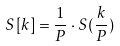Convert formula to latex. <formula><loc_0><loc_0><loc_500><loc_500>S [ k ] = \frac { 1 } { P } \cdot S ( \frac { k } { P } )</formula> 